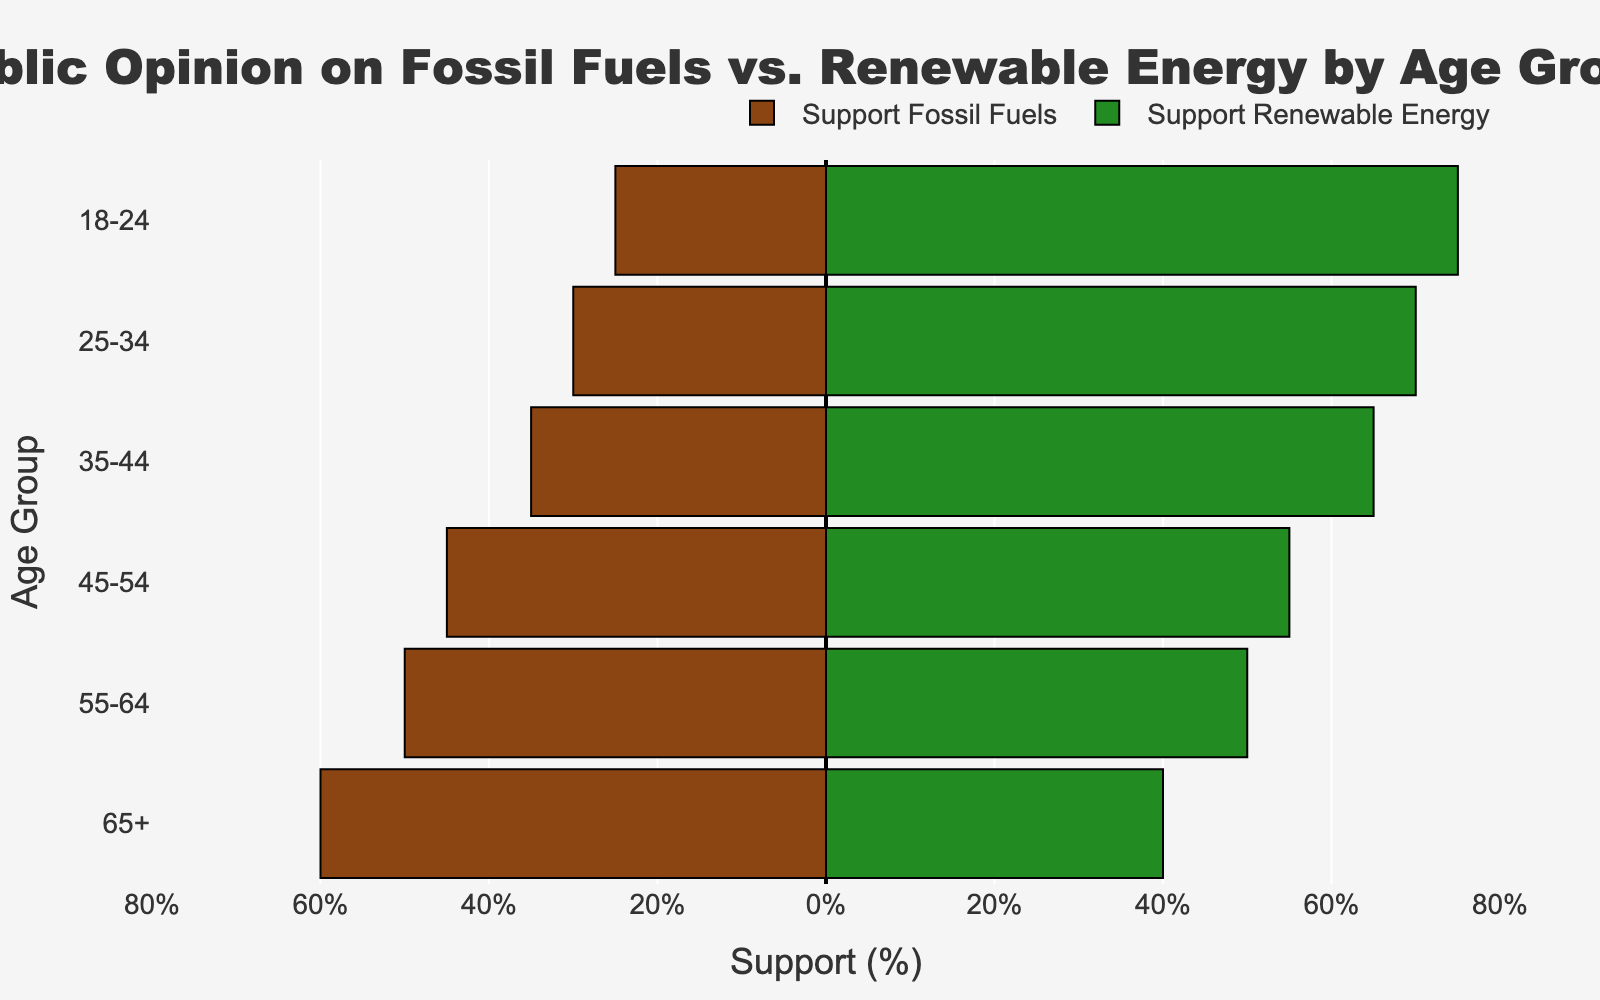What percentage of people aged 18-24 support fossil fuels? The bar for those aged 18-24 shows a "Support Fossil Fuels (%)" value of 20%, but in the chart, it indicates 25% due to the 10% "Neutral" being split, with 5% added to both supports.
Answer: 25% Which age group has the highest percentage of renewable energy support? We compare the "Support Renewable Energy (%)" bars for all age groups. The bar for the 18-24 age group extends furthest to the right, indicating the highest percentage.
Answer: 18-24 What is the difference in support for renewable energy between the 55-64 age group and the 65+ age group? The bar for the 55-64 age group shows 45% support for renewable energy, and the 65+ group shows 35% support. The difference is 45% - 35% = 10%.
Answer: 10% Which age group is the most divided in their support for fossil fuels and renewable energy? We look at the bars where both support percentages are closest. The 55-64 age group has 45% support for both fossil fuels and renewable energy, making it the most divided group.
Answer: 55-64 What is the average percentage of neutral opinions across all age groups? The neutral opinions column consistently shows 10% for every age group. Summing these and dividing by the number of age groups (6) gives an average of (10 + 10 + 10 + 10 + 10 + 10) / 6 = 10%.
Answer: 10% Is the support for fossil fuels increasing or decreasing with age? By comparing the lengths of support for fossil fuels across age groups, it's evident that support increases with age, from 25% for 18-24 to 60% for 65+.
Answer: Increasing How much more percentage support does the 18-24 age group show for renewable energy compared to the 45-54 age group? The 18-24 age group shows 70% support, and the 45-54 group shows 50%. The difference is 70% - 50% = 20%.
Answer: 20% Which age group has the smallest support for renewable energy? By observing the bars for renewable energy, the 65+ age group has the smallest extension with 35%.
Answer: 65+ What is the total support percentage for fossil fuels and renewable energy for the 35-44 age group? The support for fossil fuels is 35%, and for renewable energy, it is 65%. Combining these gives 35% + 65% = 100%, including neutral.
Answer: 100% 